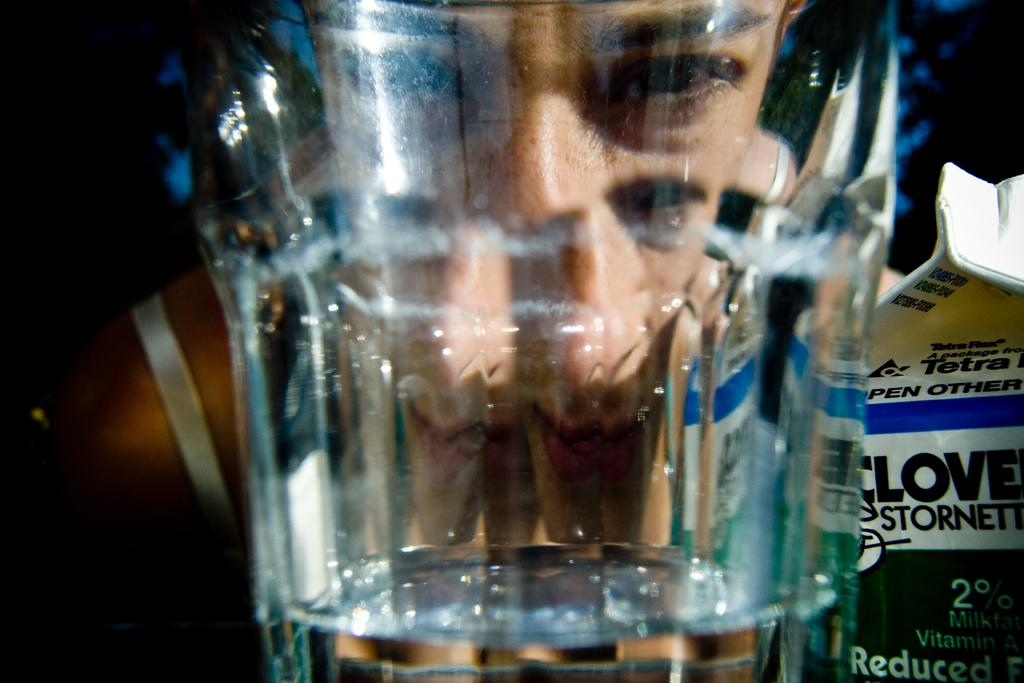What object is present in the image that is typically used for holding liquids? There is a glass in the image. Can you describe what is visible behind the glass? There is a person visible behind the glass. What other object can be seen in the image? There is a cardboard box in the image. What direction is the shirt facing in the image? There is no shirt present in the image, so it is not possible to determine the direction it might be facing. 